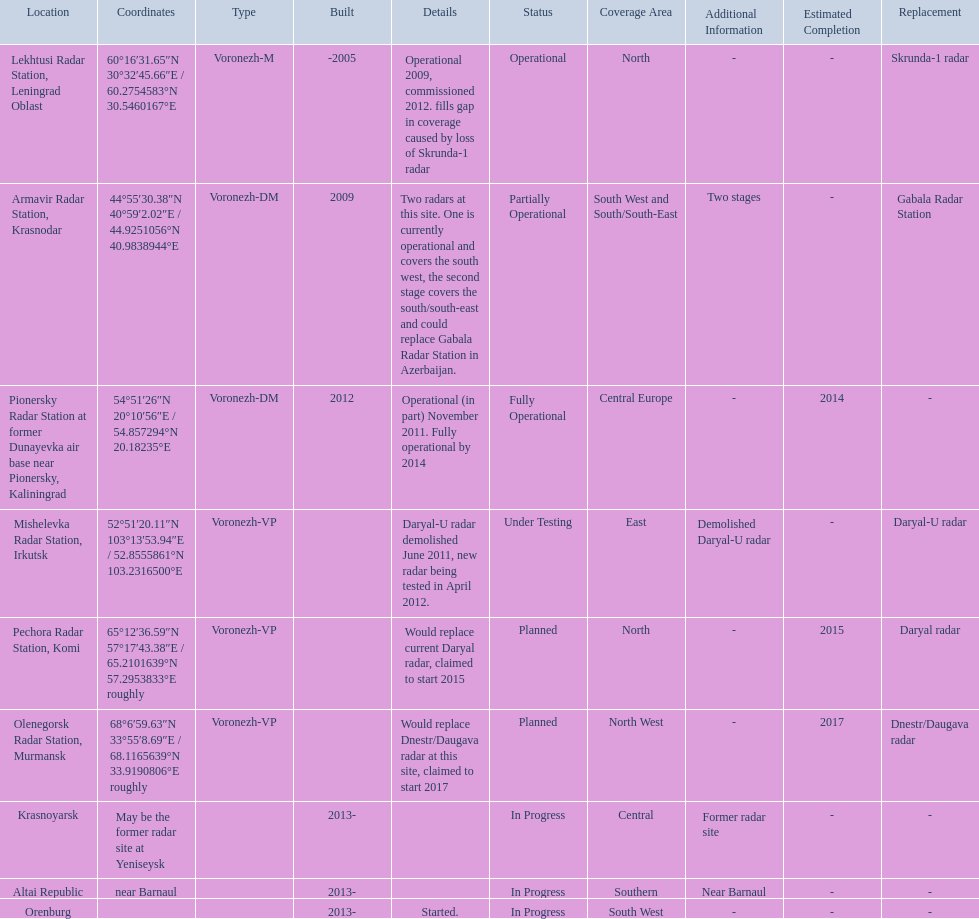What is the only radar that will start in 2015? Pechora Radar Station, Komi. 